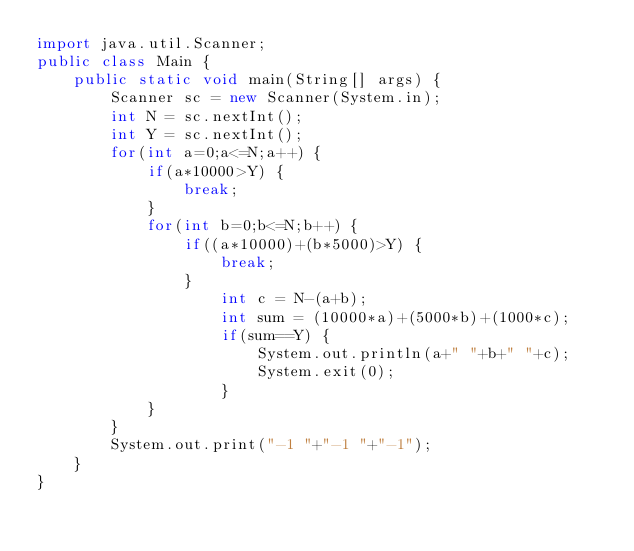<code> <loc_0><loc_0><loc_500><loc_500><_Java_>import java.util.Scanner;
public class Main {
	public static void main(String[] args) {
		Scanner sc = new Scanner(System.in);
		int N = sc.nextInt();
		int Y = sc.nextInt();
		for(int a=0;a<=N;a++) {
			if(a*10000>Y) {
				break;
			}
			for(int b=0;b<=N;b++) {
				if((a*10000)+(b*5000)>Y) {
					break;
				}
					int c = N-(a+b);
					int sum = (10000*a)+(5000*b)+(1000*c);
					if(sum==Y) {
						System.out.println(a+" "+b+" "+c);
						System.exit(0);
					}
			}
		}
		System.out.print("-1 "+"-1 "+"-1");
	}
}</code> 